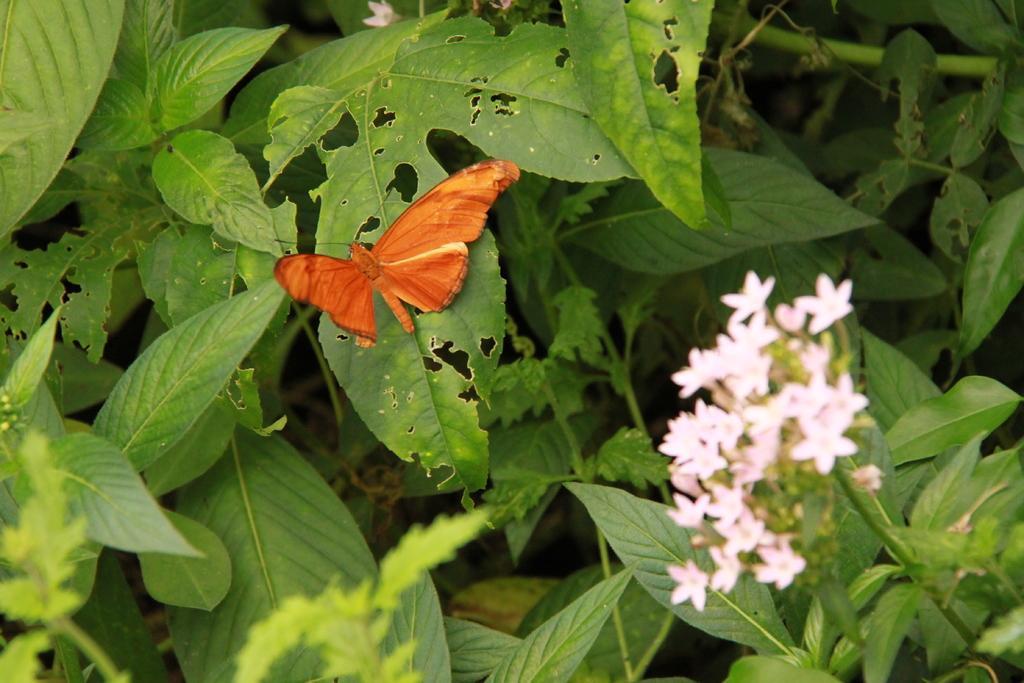In one or two sentences, can you explain what this image depicts? There is a butterfly on a leaf. There are flower plants. 